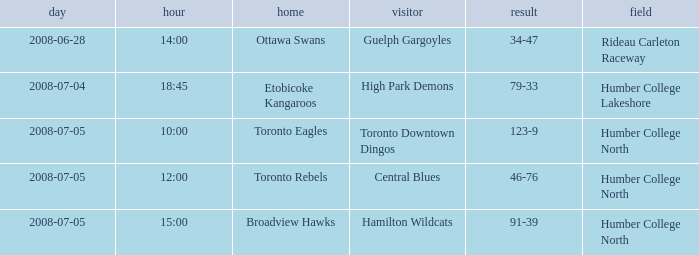What is the Date with a Time that is 18:45? 2008-07-04. 